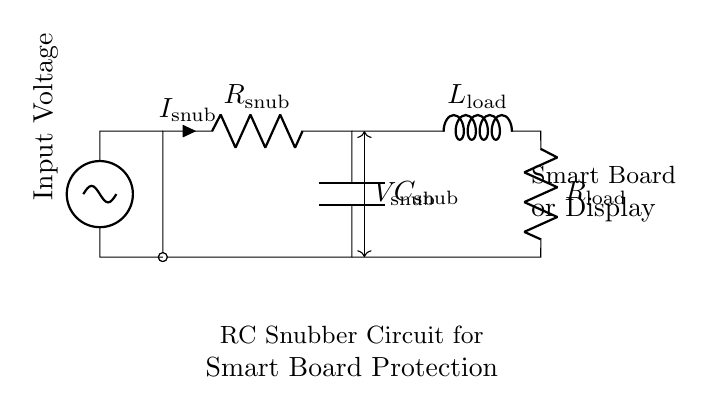What is the resistance value in the snubber circuit? The resistance in the snubber circuit is labeled as R snub, which is represented in the circuit diagram.
Answer: R snub What component is used to store energy in this circuit? The energy storage component is the capacitor, denoted as C snub in the circuit diagram, which is specifically designed to absorb and store electrical energy temporarily.
Answer: C snub What does the current notation indicate in the circuit? The current notation labeled as I snub represents the current flowing through the resistor R snub in the snubber circuit, indicating the direction of current flow.
Answer: I snub What is the purpose of the snubber circuit in this application? The snubber circuit is used to protect smart boards from voltage spikes, which helps prevent damage to sensitive electronic components.
Answer: Protects smart boards How does increasing the capacitance affect the snubber circuit? Increasing the capacitance would allow more charge to be stored, resulting in a larger ability to absorb voltage spikes, thus providing improved protection to the load.
Answer: Improved protection What is the function of the load components in this circuit? The load components, L load and R load, represent the device or system that the circuit powers, and they function as the elements that are being protected from voltage spikes by the snubber circuit.
Answer: Protects the device 